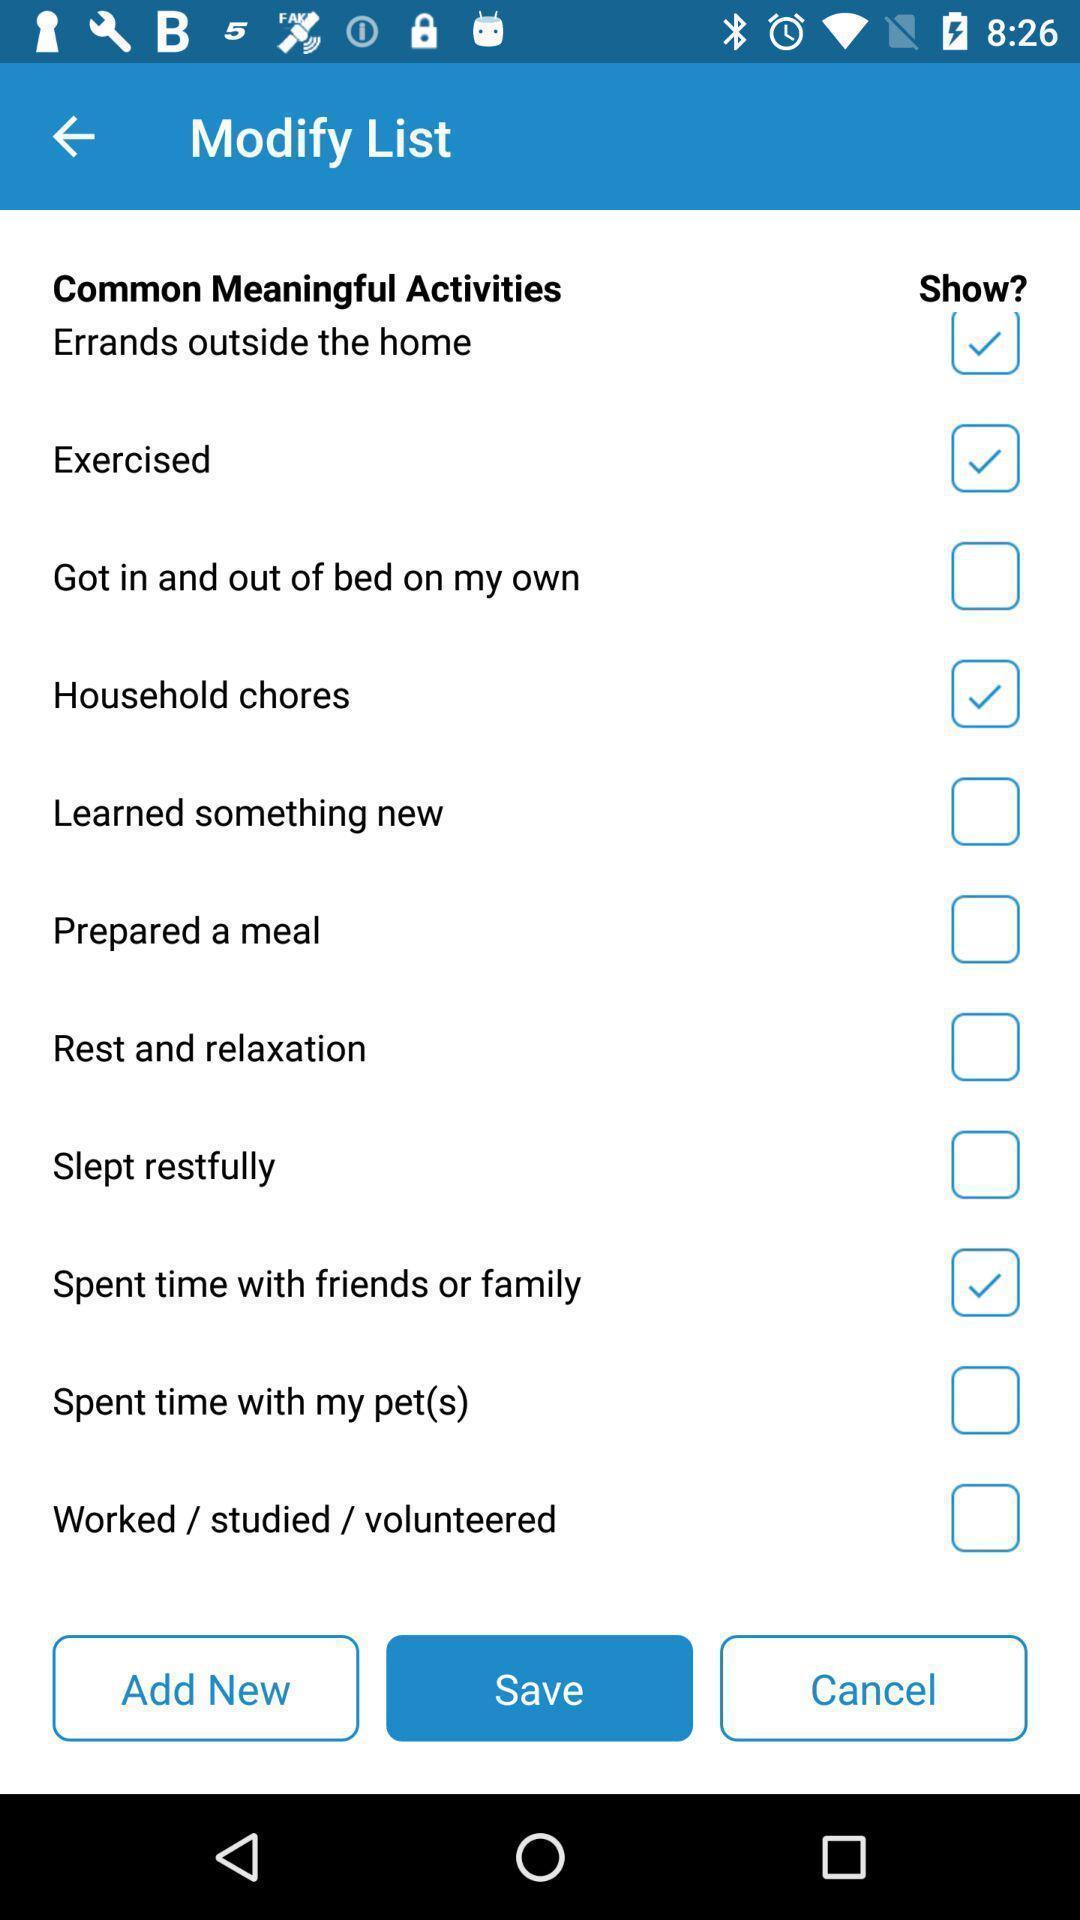Describe the key features of this screenshot. Screen showing modify list in health app. 